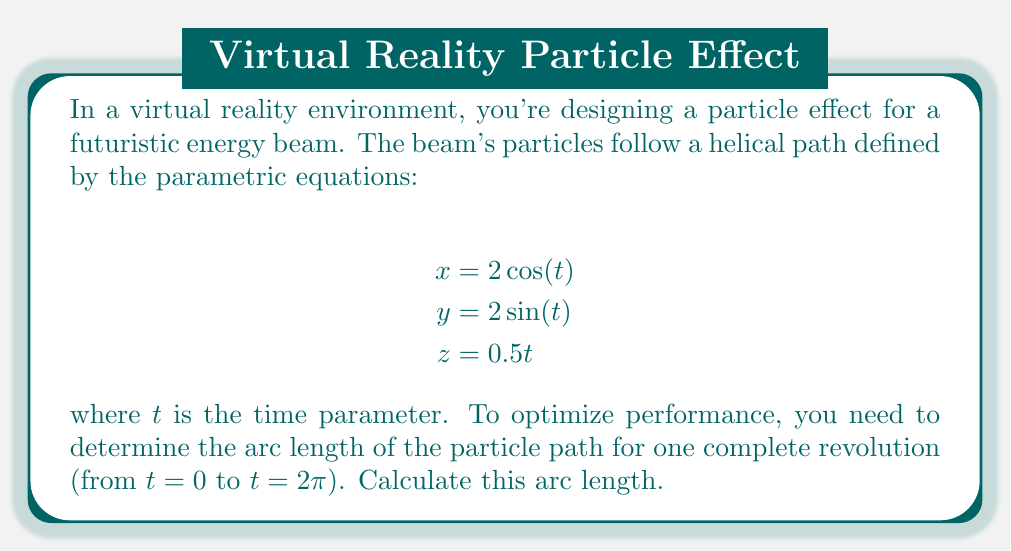What is the answer to this math problem? To solve this problem, we'll follow these steps:

1) The arc length of a parametric curve is given by the formula:

   $$L = \int_a^b \sqrt{\left(\frac{dx}{dt}\right)^2 + \left(\frac{dy}{dt}\right)^2 + \left(\frac{dz}{dt}\right)^2} dt$$

2) Let's find the derivatives:
   
   $$\frac{dx}{dt} = -2\sin(t)$$
   $$\frac{dy}{dt} = 2\cos(t)$$
   $$\frac{dz}{dt} = 0.5$$

3) Now, let's substitute these into our arc length formula:

   $$L = \int_0^{2\pi} \sqrt{(-2\sin(t))^2 + (2\cos(t))^2 + (0.5)^2} dt$$

4) Simplify under the square root:

   $$L = \int_0^{2\pi} \sqrt{4\sin^2(t) + 4\cos^2(t) + 0.25} dt$$

5) Recall that $\sin^2(t) + \cos^2(t) = 1$, so:

   $$L = \int_0^{2\pi} \sqrt{4 + 0.25} dt = \int_0^{2\pi} \sqrt{4.25} dt = \int_0^{2\pi} \sqrt{17}/2 dt$$

6) This simplifies our integral:

   $$L = \frac{\sqrt{17}}{2} \int_0^{2\pi} dt = \frac{\sqrt{17}}{2} [t]_0^{2\pi} = \frac{\sqrt{17}}{2} (2\pi - 0) = \pi\sqrt{17}$$

Thus, the arc length for one complete revolution is $\pi\sqrt{17}$.
Answer: $\pi\sqrt{17}$ 